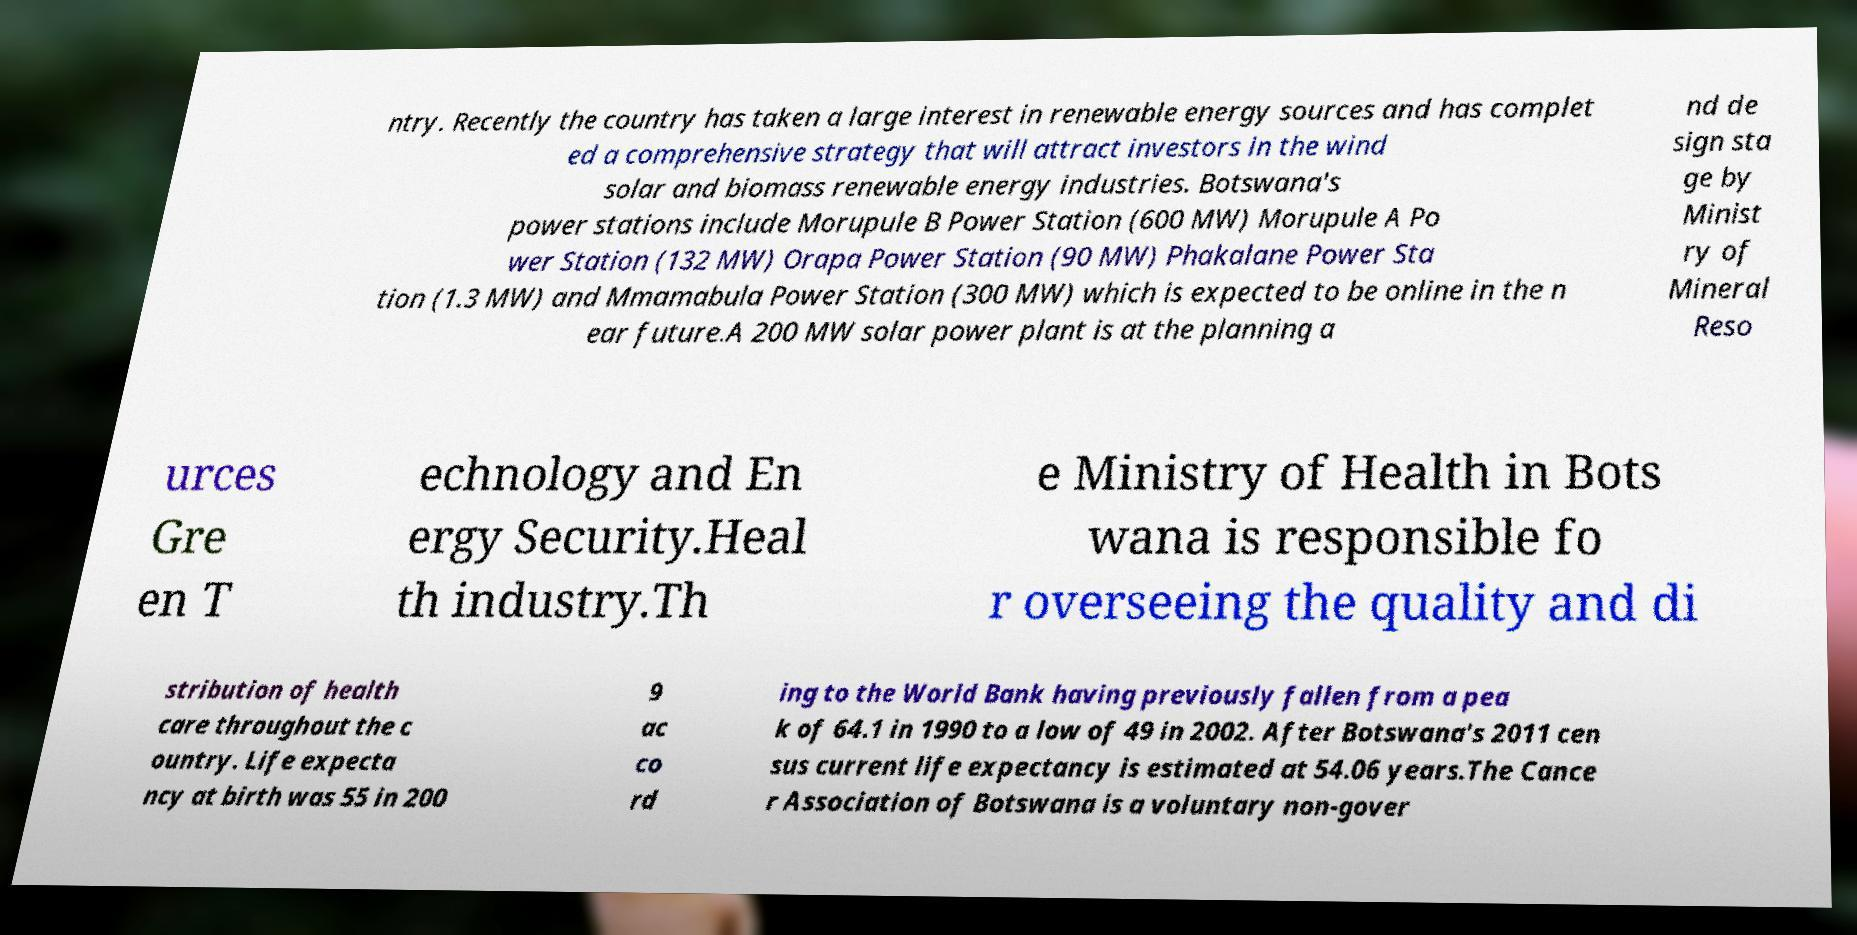Can you read and provide the text displayed in the image?This photo seems to have some interesting text. Can you extract and type it out for me? ntry. Recently the country has taken a large interest in renewable energy sources and has complet ed a comprehensive strategy that will attract investors in the wind solar and biomass renewable energy industries. Botswana's power stations include Morupule B Power Station (600 MW) Morupule A Po wer Station (132 MW) Orapa Power Station (90 MW) Phakalane Power Sta tion (1.3 MW) and Mmamabula Power Station (300 MW) which is expected to be online in the n ear future.A 200 MW solar power plant is at the planning a nd de sign sta ge by Minist ry of Mineral Reso urces Gre en T echnology and En ergy Security.Heal th industry.Th e Ministry of Health in Bots wana is responsible fo r overseeing the quality and di stribution of health care throughout the c ountry. Life expecta ncy at birth was 55 in 200 9 ac co rd ing to the World Bank having previously fallen from a pea k of 64.1 in 1990 to a low of 49 in 2002. After Botswana's 2011 cen sus current life expectancy is estimated at 54.06 years.The Cance r Association of Botswana is a voluntary non-gover 